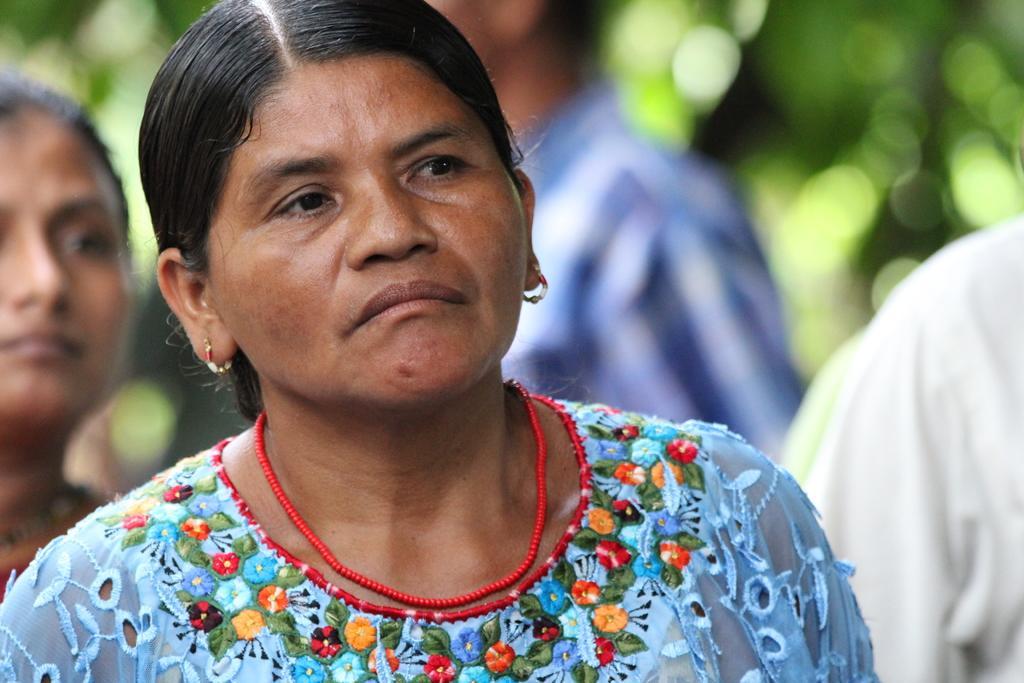Can you describe this image briefly? In this image I can see the group of people with different color dresses. And there is a blurred background. 